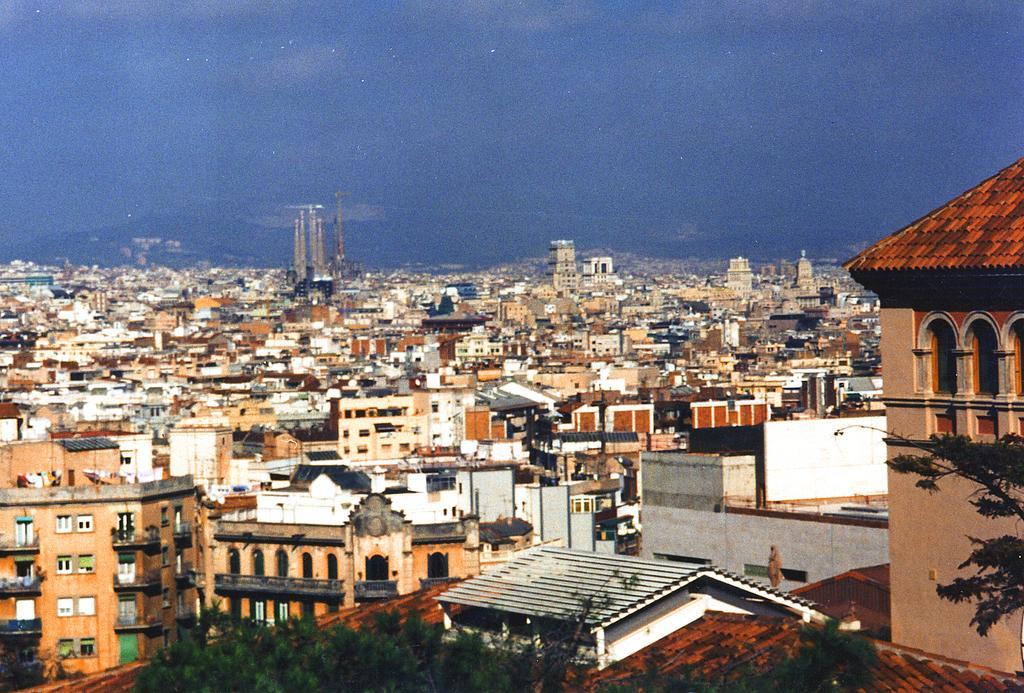In one or two sentences, can you explain what this image depicts? At the bottom of the picture, we see the trees. There are buildings and towers in the background. On the right side, we see a tree. We see hills in the background. At the top, we see the sky. 